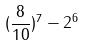<formula> <loc_0><loc_0><loc_500><loc_500>( \frac { 8 } { 1 0 } ) ^ { 7 } - 2 ^ { 6 }</formula> 